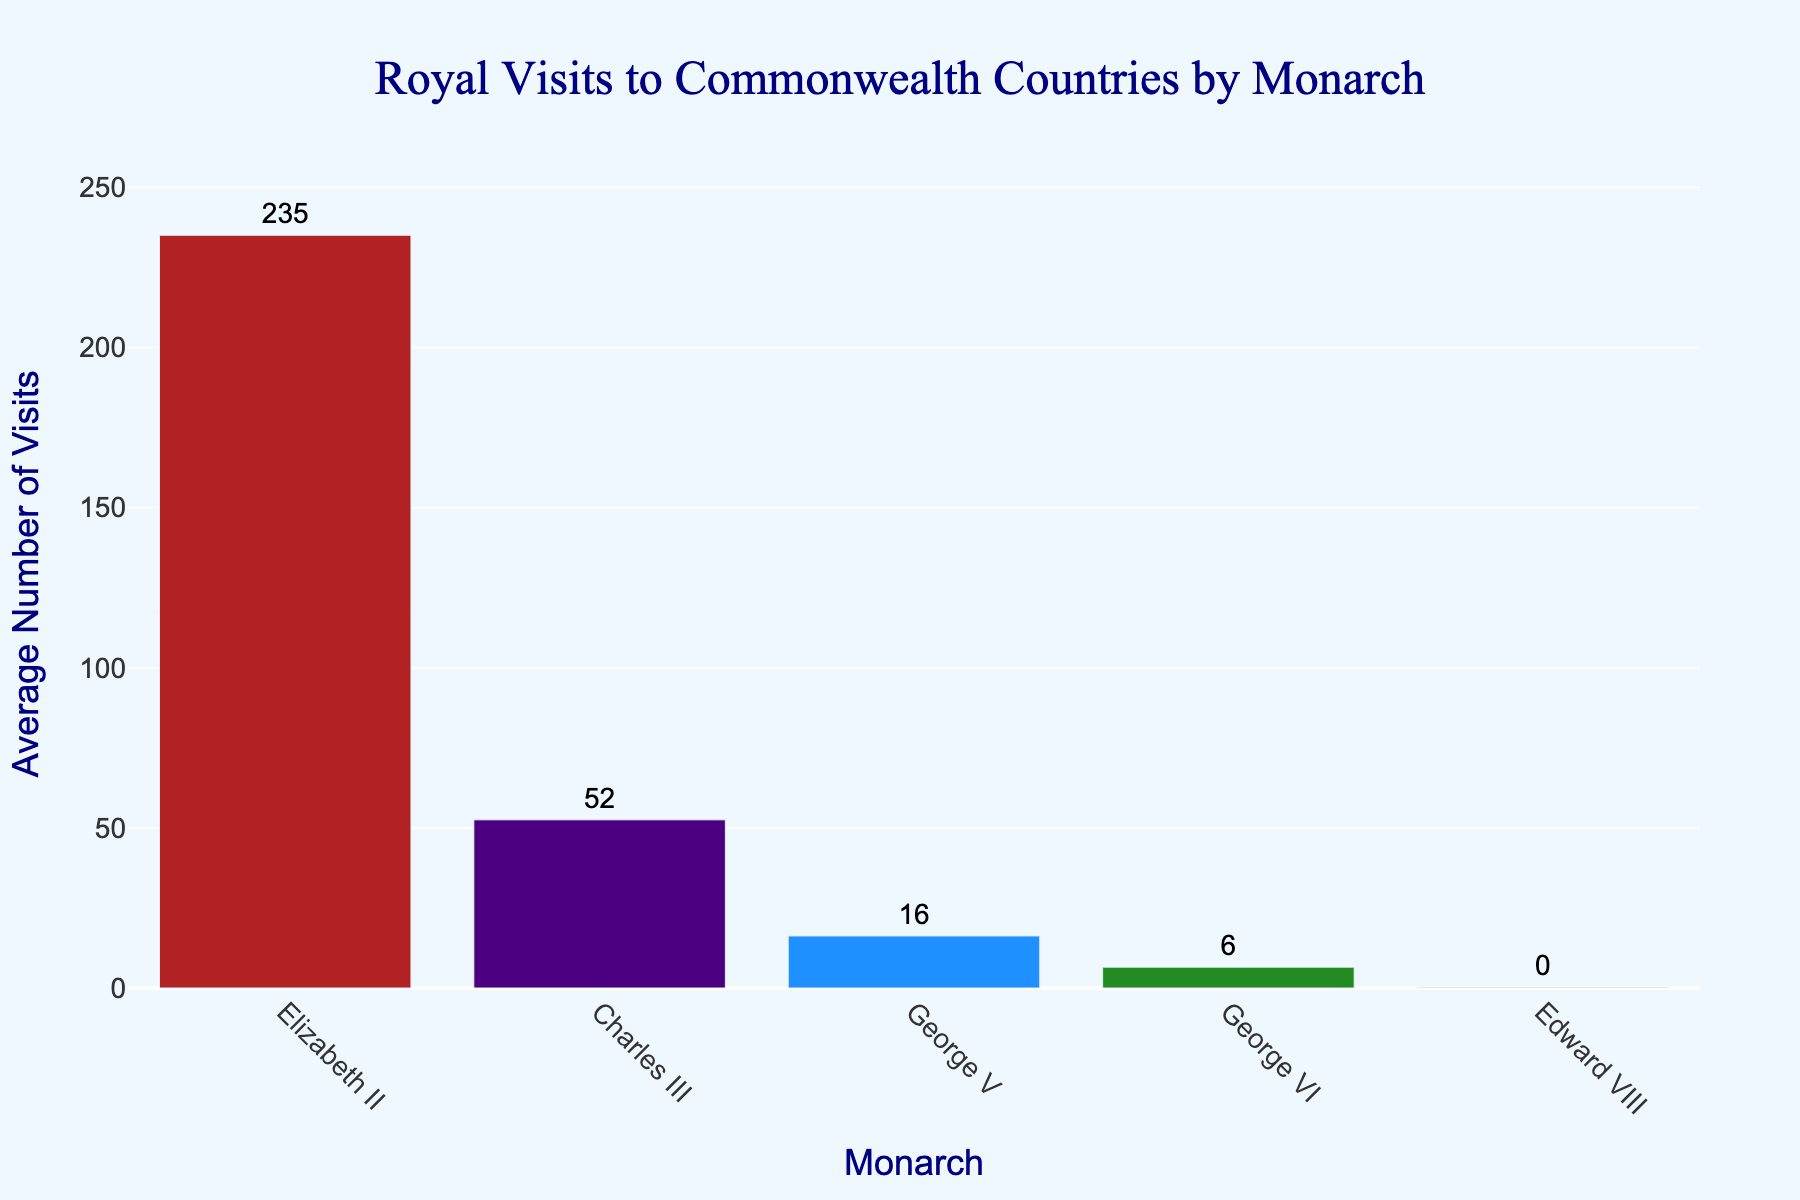Which monarch had the highest average number of Commonwealth country visits? To find the monarch with the highest average number of visits, look for the tallest bar. This represents Elizabeth II.
Answer: Elizabeth II How many more average visits did Elizabeth II undertake compared to Charles III? First, find the average number of visits for both Elizabeth II and Charles III by looking at the height of their respective bars. Then, subtract Charles III's average from Elizabeth II's average. Elizabeth II has an average of approximately 235 visits, while Charles III has about 52. The difference is 235 - 52.
Answer: 183 Which monarch visited the least number of Commonwealth countries on average? Look for the shortest bar in the chart. The bar for Edward VIII is the shortest, indicating he made the fewest visits.
Answer: Edward VIII What's the combined average number of visits for George V and George VI? Find the average number of visits for both George V and George VI. George V has an average of about 16 visits, and George VI has one of approximately 6. Summing these gives 16 + 6.
Answer: 22 Which monarch appears in the middle when ranked by the average number of Commonwealth country visits? To determine the median monarch, arrange the monarchs by their average visits in ascending order: Edward VIII, George VI, George V, Charles III, Elizabeth II. The monarch in the middle position is George V.
Answer: George V By how much does the average number of visits for Elizabeth II exceed that of George V? Look at the height of the bars for Elizabeth II and George V. Elizabeth II has an average of about 235 visits, and George V has an average of about 16 visits. The difference is 235 - 16.
Answer: 219 How many monarchs have an average number of visits greater than 20? Check the bars whose heights exceed the 20 visit mark. Only Elizabeth II and Charles III fit this criterion.
Answer: 2 Compare the average number of visits between the last two monarchs, Charles III and Elizabeth II. Identify the precise average values for Charles III and Elizabeth II from the chart. Charles III has about 52 visits, while Elizabeth II has about 235 visits. Elizabeth II has a higher average than Charles III.
Answer: Elizabeth II What is the average number of visits across all monarchs? Find the average number of visits for each monarch, sum these values, then divide by the number of monarchs. Average visits are: Elizabeth II = 235, Charles III = 52, George V = 16, George VI = 6, Edward VIII = 0. Sum = 235 + 52 + 16 + 6 + 0 = 309. Divide by 5 monarchs, 309/5.
Answer: 61.8 Are there any monarchs with the same average number of Commonwealth country visits? Check the bars to see if any have the same height. All monarchs have different heights representing their distinct average visit numbers.
Answer: No 